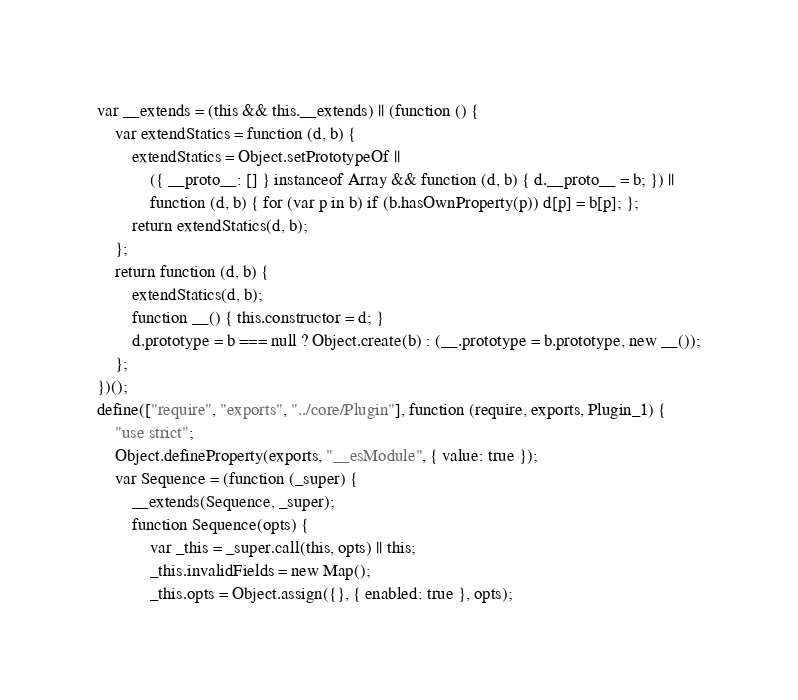Convert code to text. <code><loc_0><loc_0><loc_500><loc_500><_JavaScript_>var __extends = (this && this.__extends) || (function () {
    var extendStatics = function (d, b) {
        extendStatics = Object.setPrototypeOf ||
            ({ __proto__: [] } instanceof Array && function (d, b) { d.__proto__ = b; }) ||
            function (d, b) { for (var p in b) if (b.hasOwnProperty(p)) d[p] = b[p]; };
        return extendStatics(d, b);
    };
    return function (d, b) {
        extendStatics(d, b);
        function __() { this.constructor = d; }
        d.prototype = b === null ? Object.create(b) : (__.prototype = b.prototype, new __());
    };
})();
define(["require", "exports", "../core/Plugin"], function (require, exports, Plugin_1) {
    "use strict";
    Object.defineProperty(exports, "__esModule", { value: true });
    var Sequence = (function (_super) {
        __extends(Sequence, _super);
        function Sequence(opts) {
            var _this = _super.call(this, opts) || this;
            _this.invalidFields = new Map();
            _this.opts = Object.assign({}, { enabled: true }, opts);</code> 